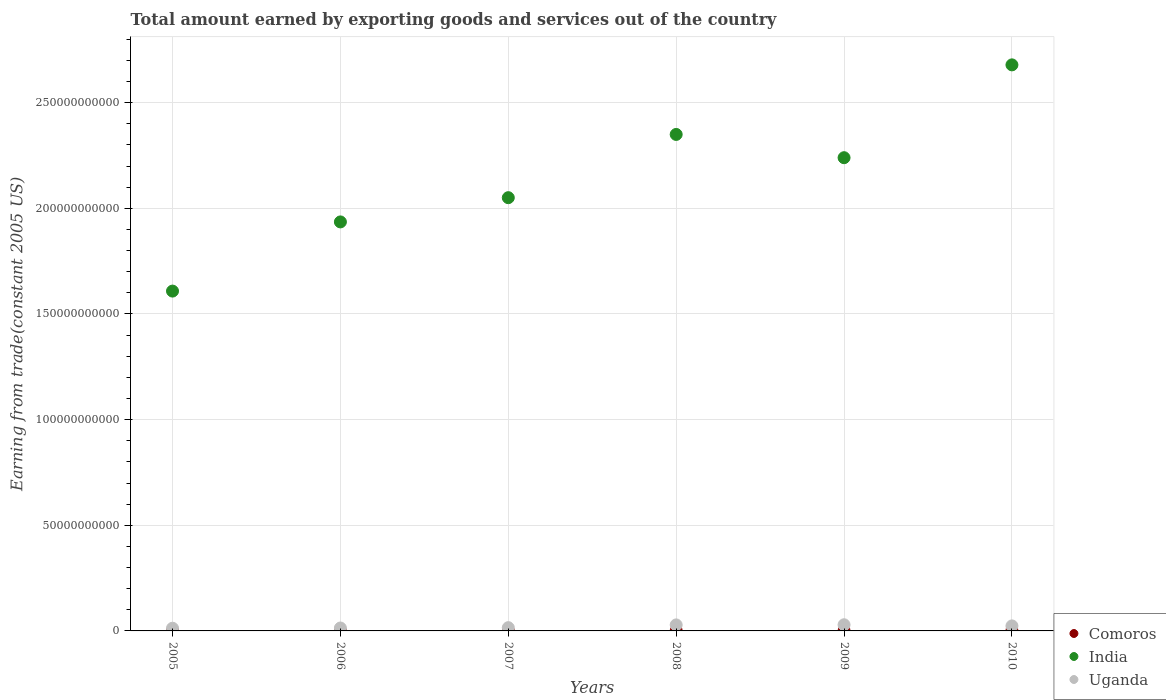How many different coloured dotlines are there?
Make the answer very short. 3. What is the total amount earned by exporting goods and services in India in 2009?
Ensure brevity in your answer.  2.24e+11. Across all years, what is the maximum total amount earned by exporting goods and services in Uganda?
Offer a very short reply. 2.91e+09. Across all years, what is the minimum total amount earned by exporting goods and services in Comoros?
Offer a terse response. 5.71e+07. In which year was the total amount earned by exporting goods and services in Uganda maximum?
Ensure brevity in your answer.  2009. In which year was the total amount earned by exporting goods and services in Uganda minimum?
Give a very brief answer. 2005. What is the total total amount earned by exporting goods and services in India in the graph?
Your response must be concise. 1.29e+12. What is the difference between the total amount earned by exporting goods and services in Uganda in 2005 and that in 2010?
Your response must be concise. -1.09e+09. What is the difference between the total amount earned by exporting goods and services in Uganda in 2009 and the total amount earned by exporting goods and services in Comoros in 2010?
Offer a very short reply. 2.81e+09. What is the average total amount earned by exporting goods and services in Uganda per year?
Your answer should be very brief. 2.06e+09. In the year 2005, what is the difference between the total amount earned by exporting goods and services in Uganda and total amount earned by exporting goods and services in India?
Give a very brief answer. -1.60e+11. In how many years, is the total amount earned by exporting goods and services in Uganda greater than 40000000000 US$?
Your answer should be very brief. 0. What is the ratio of the total amount earned by exporting goods and services in India in 2006 to that in 2010?
Offer a very short reply. 0.72. Is the total amount earned by exporting goods and services in Comoros in 2005 less than that in 2008?
Ensure brevity in your answer.  Yes. What is the difference between the highest and the second highest total amount earned by exporting goods and services in India?
Your answer should be very brief. 3.29e+1. What is the difference between the highest and the lowest total amount earned by exporting goods and services in Comoros?
Your answer should be compact. 5.06e+07. Is it the case that in every year, the sum of the total amount earned by exporting goods and services in Comoros and total amount earned by exporting goods and services in Uganda  is greater than the total amount earned by exporting goods and services in India?
Ensure brevity in your answer.  No. Is the total amount earned by exporting goods and services in Comoros strictly greater than the total amount earned by exporting goods and services in Uganda over the years?
Your answer should be compact. No. How many dotlines are there?
Your answer should be compact. 3. How many years are there in the graph?
Offer a very short reply. 6. What is the difference between two consecutive major ticks on the Y-axis?
Your answer should be very brief. 5.00e+1. Where does the legend appear in the graph?
Give a very brief answer. Bottom right. How many legend labels are there?
Your response must be concise. 3. What is the title of the graph?
Make the answer very short. Total amount earned by exporting goods and services out of the country. Does "Virgin Islands" appear as one of the legend labels in the graph?
Offer a very short reply. No. What is the label or title of the X-axis?
Provide a succinct answer. Years. What is the label or title of the Y-axis?
Your answer should be very brief. Earning from trade(constant 2005 US). What is the Earning from trade(constant 2005 US) of Comoros in 2005?
Provide a short and direct response. 5.71e+07. What is the Earning from trade(constant 2005 US) in India in 2005?
Provide a succinct answer. 1.61e+11. What is the Earning from trade(constant 2005 US) of Uganda in 2005?
Give a very brief answer. 1.28e+09. What is the Earning from trade(constant 2005 US) of Comoros in 2006?
Ensure brevity in your answer.  5.81e+07. What is the Earning from trade(constant 2005 US) in India in 2006?
Offer a very short reply. 1.94e+11. What is the Earning from trade(constant 2005 US) in Uganda in 2006?
Offer a terse response. 1.38e+09. What is the Earning from trade(constant 2005 US) in Comoros in 2007?
Your answer should be compact. 9.43e+07. What is the Earning from trade(constant 2005 US) in India in 2007?
Ensure brevity in your answer.  2.05e+11. What is the Earning from trade(constant 2005 US) in Uganda in 2007?
Your answer should be compact. 1.54e+09. What is the Earning from trade(constant 2005 US) in Comoros in 2008?
Keep it short and to the point. 9.09e+07. What is the Earning from trade(constant 2005 US) in India in 2008?
Keep it short and to the point. 2.35e+11. What is the Earning from trade(constant 2005 US) in Uganda in 2008?
Ensure brevity in your answer.  2.85e+09. What is the Earning from trade(constant 2005 US) in Comoros in 2009?
Your response must be concise. 8.47e+07. What is the Earning from trade(constant 2005 US) of India in 2009?
Offer a very short reply. 2.24e+11. What is the Earning from trade(constant 2005 US) in Uganda in 2009?
Make the answer very short. 2.91e+09. What is the Earning from trade(constant 2005 US) of Comoros in 2010?
Provide a succinct answer. 1.08e+08. What is the Earning from trade(constant 2005 US) in India in 2010?
Make the answer very short. 2.68e+11. What is the Earning from trade(constant 2005 US) in Uganda in 2010?
Offer a terse response. 2.37e+09. Across all years, what is the maximum Earning from trade(constant 2005 US) of Comoros?
Your response must be concise. 1.08e+08. Across all years, what is the maximum Earning from trade(constant 2005 US) in India?
Offer a very short reply. 2.68e+11. Across all years, what is the maximum Earning from trade(constant 2005 US) of Uganda?
Your response must be concise. 2.91e+09. Across all years, what is the minimum Earning from trade(constant 2005 US) in Comoros?
Provide a succinct answer. 5.71e+07. Across all years, what is the minimum Earning from trade(constant 2005 US) in India?
Provide a succinct answer. 1.61e+11. Across all years, what is the minimum Earning from trade(constant 2005 US) in Uganda?
Ensure brevity in your answer.  1.28e+09. What is the total Earning from trade(constant 2005 US) of Comoros in the graph?
Your answer should be compact. 4.93e+08. What is the total Earning from trade(constant 2005 US) in India in the graph?
Your response must be concise. 1.29e+12. What is the total Earning from trade(constant 2005 US) in Uganda in the graph?
Ensure brevity in your answer.  1.23e+1. What is the difference between the Earning from trade(constant 2005 US) of Comoros in 2005 and that in 2006?
Offer a terse response. -9.93e+05. What is the difference between the Earning from trade(constant 2005 US) in India in 2005 and that in 2006?
Keep it short and to the point. -3.27e+1. What is the difference between the Earning from trade(constant 2005 US) of Uganda in 2005 and that in 2006?
Your answer should be very brief. -9.92e+07. What is the difference between the Earning from trade(constant 2005 US) in Comoros in 2005 and that in 2007?
Provide a succinct answer. -3.72e+07. What is the difference between the Earning from trade(constant 2005 US) in India in 2005 and that in 2007?
Offer a very short reply. -4.42e+1. What is the difference between the Earning from trade(constant 2005 US) of Uganda in 2005 and that in 2007?
Your response must be concise. -2.66e+08. What is the difference between the Earning from trade(constant 2005 US) in Comoros in 2005 and that in 2008?
Your response must be concise. -3.38e+07. What is the difference between the Earning from trade(constant 2005 US) in India in 2005 and that in 2008?
Your response must be concise. -7.41e+1. What is the difference between the Earning from trade(constant 2005 US) of Uganda in 2005 and that in 2008?
Ensure brevity in your answer.  -1.57e+09. What is the difference between the Earning from trade(constant 2005 US) in Comoros in 2005 and that in 2009?
Offer a very short reply. -2.76e+07. What is the difference between the Earning from trade(constant 2005 US) of India in 2005 and that in 2009?
Your answer should be compact. -6.31e+1. What is the difference between the Earning from trade(constant 2005 US) in Uganda in 2005 and that in 2009?
Your answer should be compact. -1.64e+09. What is the difference between the Earning from trade(constant 2005 US) of Comoros in 2005 and that in 2010?
Provide a succinct answer. -5.06e+07. What is the difference between the Earning from trade(constant 2005 US) of India in 2005 and that in 2010?
Keep it short and to the point. -1.07e+11. What is the difference between the Earning from trade(constant 2005 US) in Uganda in 2005 and that in 2010?
Your answer should be very brief. -1.09e+09. What is the difference between the Earning from trade(constant 2005 US) in Comoros in 2006 and that in 2007?
Give a very brief answer. -3.62e+07. What is the difference between the Earning from trade(constant 2005 US) in India in 2006 and that in 2007?
Give a very brief answer. -1.15e+1. What is the difference between the Earning from trade(constant 2005 US) of Uganda in 2006 and that in 2007?
Your answer should be compact. -1.67e+08. What is the difference between the Earning from trade(constant 2005 US) of Comoros in 2006 and that in 2008?
Your answer should be very brief. -3.28e+07. What is the difference between the Earning from trade(constant 2005 US) of India in 2006 and that in 2008?
Your response must be concise. -4.14e+1. What is the difference between the Earning from trade(constant 2005 US) in Uganda in 2006 and that in 2008?
Provide a short and direct response. -1.47e+09. What is the difference between the Earning from trade(constant 2005 US) in Comoros in 2006 and that in 2009?
Give a very brief answer. -2.66e+07. What is the difference between the Earning from trade(constant 2005 US) in India in 2006 and that in 2009?
Offer a terse response. -3.04e+1. What is the difference between the Earning from trade(constant 2005 US) in Uganda in 2006 and that in 2009?
Provide a succinct answer. -1.54e+09. What is the difference between the Earning from trade(constant 2005 US) of Comoros in 2006 and that in 2010?
Ensure brevity in your answer.  -4.97e+07. What is the difference between the Earning from trade(constant 2005 US) of India in 2006 and that in 2010?
Offer a very short reply. -7.43e+1. What is the difference between the Earning from trade(constant 2005 US) in Uganda in 2006 and that in 2010?
Your answer should be very brief. -9.94e+08. What is the difference between the Earning from trade(constant 2005 US) in Comoros in 2007 and that in 2008?
Give a very brief answer. 3.33e+06. What is the difference between the Earning from trade(constant 2005 US) in India in 2007 and that in 2008?
Offer a very short reply. -2.99e+1. What is the difference between the Earning from trade(constant 2005 US) of Uganda in 2007 and that in 2008?
Make the answer very short. -1.30e+09. What is the difference between the Earning from trade(constant 2005 US) of Comoros in 2007 and that in 2009?
Offer a terse response. 9.60e+06. What is the difference between the Earning from trade(constant 2005 US) in India in 2007 and that in 2009?
Your response must be concise. -1.89e+1. What is the difference between the Earning from trade(constant 2005 US) in Uganda in 2007 and that in 2009?
Give a very brief answer. -1.37e+09. What is the difference between the Earning from trade(constant 2005 US) in Comoros in 2007 and that in 2010?
Give a very brief answer. -1.35e+07. What is the difference between the Earning from trade(constant 2005 US) of India in 2007 and that in 2010?
Provide a short and direct response. -6.29e+1. What is the difference between the Earning from trade(constant 2005 US) in Uganda in 2007 and that in 2010?
Keep it short and to the point. -8.27e+08. What is the difference between the Earning from trade(constant 2005 US) in Comoros in 2008 and that in 2009?
Your answer should be compact. 6.27e+06. What is the difference between the Earning from trade(constant 2005 US) in India in 2008 and that in 2009?
Make the answer very short. 1.10e+1. What is the difference between the Earning from trade(constant 2005 US) in Uganda in 2008 and that in 2009?
Your response must be concise. -6.62e+07. What is the difference between the Earning from trade(constant 2005 US) in Comoros in 2008 and that in 2010?
Keep it short and to the point. -1.68e+07. What is the difference between the Earning from trade(constant 2005 US) of India in 2008 and that in 2010?
Your response must be concise. -3.29e+1. What is the difference between the Earning from trade(constant 2005 US) of Uganda in 2008 and that in 2010?
Keep it short and to the point. 4.77e+08. What is the difference between the Earning from trade(constant 2005 US) in Comoros in 2009 and that in 2010?
Your answer should be compact. -2.31e+07. What is the difference between the Earning from trade(constant 2005 US) in India in 2009 and that in 2010?
Provide a short and direct response. -4.39e+1. What is the difference between the Earning from trade(constant 2005 US) of Uganda in 2009 and that in 2010?
Make the answer very short. 5.43e+08. What is the difference between the Earning from trade(constant 2005 US) of Comoros in 2005 and the Earning from trade(constant 2005 US) of India in 2006?
Offer a terse response. -1.94e+11. What is the difference between the Earning from trade(constant 2005 US) of Comoros in 2005 and the Earning from trade(constant 2005 US) of Uganda in 2006?
Offer a terse response. -1.32e+09. What is the difference between the Earning from trade(constant 2005 US) in India in 2005 and the Earning from trade(constant 2005 US) in Uganda in 2006?
Make the answer very short. 1.59e+11. What is the difference between the Earning from trade(constant 2005 US) in Comoros in 2005 and the Earning from trade(constant 2005 US) in India in 2007?
Offer a very short reply. -2.05e+11. What is the difference between the Earning from trade(constant 2005 US) of Comoros in 2005 and the Earning from trade(constant 2005 US) of Uganda in 2007?
Give a very brief answer. -1.49e+09. What is the difference between the Earning from trade(constant 2005 US) in India in 2005 and the Earning from trade(constant 2005 US) in Uganda in 2007?
Your answer should be very brief. 1.59e+11. What is the difference between the Earning from trade(constant 2005 US) in Comoros in 2005 and the Earning from trade(constant 2005 US) in India in 2008?
Your answer should be very brief. -2.35e+11. What is the difference between the Earning from trade(constant 2005 US) in Comoros in 2005 and the Earning from trade(constant 2005 US) in Uganda in 2008?
Offer a terse response. -2.79e+09. What is the difference between the Earning from trade(constant 2005 US) in India in 2005 and the Earning from trade(constant 2005 US) in Uganda in 2008?
Provide a short and direct response. 1.58e+11. What is the difference between the Earning from trade(constant 2005 US) of Comoros in 2005 and the Earning from trade(constant 2005 US) of India in 2009?
Your answer should be compact. -2.24e+11. What is the difference between the Earning from trade(constant 2005 US) in Comoros in 2005 and the Earning from trade(constant 2005 US) in Uganda in 2009?
Your response must be concise. -2.86e+09. What is the difference between the Earning from trade(constant 2005 US) in India in 2005 and the Earning from trade(constant 2005 US) in Uganda in 2009?
Give a very brief answer. 1.58e+11. What is the difference between the Earning from trade(constant 2005 US) of Comoros in 2005 and the Earning from trade(constant 2005 US) of India in 2010?
Your answer should be very brief. -2.68e+11. What is the difference between the Earning from trade(constant 2005 US) in Comoros in 2005 and the Earning from trade(constant 2005 US) in Uganda in 2010?
Provide a short and direct response. -2.31e+09. What is the difference between the Earning from trade(constant 2005 US) of India in 2005 and the Earning from trade(constant 2005 US) of Uganda in 2010?
Your answer should be compact. 1.58e+11. What is the difference between the Earning from trade(constant 2005 US) in Comoros in 2006 and the Earning from trade(constant 2005 US) in India in 2007?
Keep it short and to the point. -2.05e+11. What is the difference between the Earning from trade(constant 2005 US) of Comoros in 2006 and the Earning from trade(constant 2005 US) of Uganda in 2007?
Your answer should be compact. -1.49e+09. What is the difference between the Earning from trade(constant 2005 US) in India in 2006 and the Earning from trade(constant 2005 US) in Uganda in 2007?
Offer a very short reply. 1.92e+11. What is the difference between the Earning from trade(constant 2005 US) of Comoros in 2006 and the Earning from trade(constant 2005 US) of India in 2008?
Provide a succinct answer. -2.35e+11. What is the difference between the Earning from trade(constant 2005 US) in Comoros in 2006 and the Earning from trade(constant 2005 US) in Uganda in 2008?
Provide a short and direct response. -2.79e+09. What is the difference between the Earning from trade(constant 2005 US) in India in 2006 and the Earning from trade(constant 2005 US) in Uganda in 2008?
Your response must be concise. 1.91e+11. What is the difference between the Earning from trade(constant 2005 US) of Comoros in 2006 and the Earning from trade(constant 2005 US) of India in 2009?
Provide a succinct answer. -2.24e+11. What is the difference between the Earning from trade(constant 2005 US) of Comoros in 2006 and the Earning from trade(constant 2005 US) of Uganda in 2009?
Offer a terse response. -2.86e+09. What is the difference between the Earning from trade(constant 2005 US) of India in 2006 and the Earning from trade(constant 2005 US) of Uganda in 2009?
Give a very brief answer. 1.91e+11. What is the difference between the Earning from trade(constant 2005 US) of Comoros in 2006 and the Earning from trade(constant 2005 US) of India in 2010?
Ensure brevity in your answer.  -2.68e+11. What is the difference between the Earning from trade(constant 2005 US) in Comoros in 2006 and the Earning from trade(constant 2005 US) in Uganda in 2010?
Offer a very short reply. -2.31e+09. What is the difference between the Earning from trade(constant 2005 US) in India in 2006 and the Earning from trade(constant 2005 US) in Uganda in 2010?
Your answer should be compact. 1.91e+11. What is the difference between the Earning from trade(constant 2005 US) of Comoros in 2007 and the Earning from trade(constant 2005 US) of India in 2008?
Provide a short and direct response. -2.35e+11. What is the difference between the Earning from trade(constant 2005 US) of Comoros in 2007 and the Earning from trade(constant 2005 US) of Uganda in 2008?
Provide a succinct answer. -2.75e+09. What is the difference between the Earning from trade(constant 2005 US) of India in 2007 and the Earning from trade(constant 2005 US) of Uganda in 2008?
Your answer should be compact. 2.02e+11. What is the difference between the Earning from trade(constant 2005 US) in Comoros in 2007 and the Earning from trade(constant 2005 US) in India in 2009?
Provide a succinct answer. -2.24e+11. What is the difference between the Earning from trade(constant 2005 US) of Comoros in 2007 and the Earning from trade(constant 2005 US) of Uganda in 2009?
Your answer should be compact. -2.82e+09. What is the difference between the Earning from trade(constant 2005 US) in India in 2007 and the Earning from trade(constant 2005 US) in Uganda in 2009?
Offer a very short reply. 2.02e+11. What is the difference between the Earning from trade(constant 2005 US) in Comoros in 2007 and the Earning from trade(constant 2005 US) in India in 2010?
Your answer should be compact. -2.68e+11. What is the difference between the Earning from trade(constant 2005 US) in Comoros in 2007 and the Earning from trade(constant 2005 US) in Uganda in 2010?
Your answer should be very brief. -2.28e+09. What is the difference between the Earning from trade(constant 2005 US) of India in 2007 and the Earning from trade(constant 2005 US) of Uganda in 2010?
Your answer should be compact. 2.03e+11. What is the difference between the Earning from trade(constant 2005 US) of Comoros in 2008 and the Earning from trade(constant 2005 US) of India in 2009?
Your answer should be very brief. -2.24e+11. What is the difference between the Earning from trade(constant 2005 US) of Comoros in 2008 and the Earning from trade(constant 2005 US) of Uganda in 2009?
Provide a succinct answer. -2.82e+09. What is the difference between the Earning from trade(constant 2005 US) of India in 2008 and the Earning from trade(constant 2005 US) of Uganda in 2009?
Keep it short and to the point. 2.32e+11. What is the difference between the Earning from trade(constant 2005 US) of Comoros in 2008 and the Earning from trade(constant 2005 US) of India in 2010?
Give a very brief answer. -2.68e+11. What is the difference between the Earning from trade(constant 2005 US) in Comoros in 2008 and the Earning from trade(constant 2005 US) in Uganda in 2010?
Your answer should be compact. -2.28e+09. What is the difference between the Earning from trade(constant 2005 US) of India in 2008 and the Earning from trade(constant 2005 US) of Uganda in 2010?
Ensure brevity in your answer.  2.33e+11. What is the difference between the Earning from trade(constant 2005 US) in Comoros in 2009 and the Earning from trade(constant 2005 US) in India in 2010?
Make the answer very short. -2.68e+11. What is the difference between the Earning from trade(constant 2005 US) of Comoros in 2009 and the Earning from trade(constant 2005 US) of Uganda in 2010?
Provide a short and direct response. -2.29e+09. What is the difference between the Earning from trade(constant 2005 US) of India in 2009 and the Earning from trade(constant 2005 US) of Uganda in 2010?
Make the answer very short. 2.22e+11. What is the average Earning from trade(constant 2005 US) of Comoros per year?
Offer a very short reply. 8.21e+07. What is the average Earning from trade(constant 2005 US) in India per year?
Give a very brief answer. 2.14e+11. What is the average Earning from trade(constant 2005 US) in Uganda per year?
Your answer should be very brief. 2.06e+09. In the year 2005, what is the difference between the Earning from trade(constant 2005 US) of Comoros and Earning from trade(constant 2005 US) of India?
Offer a terse response. -1.61e+11. In the year 2005, what is the difference between the Earning from trade(constant 2005 US) in Comoros and Earning from trade(constant 2005 US) in Uganda?
Your answer should be very brief. -1.22e+09. In the year 2005, what is the difference between the Earning from trade(constant 2005 US) in India and Earning from trade(constant 2005 US) in Uganda?
Offer a terse response. 1.60e+11. In the year 2006, what is the difference between the Earning from trade(constant 2005 US) in Comoros and Earning from trade(constant 2005 US) in India?
Your answer should be very brief. -1.94e+11. In the year 2006, what is the difference between the Earning from trade(constant 2005 US) of Comoros and Earning from trade(constant 2005 US) of Uganda?
Your answer should be compact. -1.32e+09. In the year 2006, what is the difference between the Earning from trade(constant 2005 US) in India and Earning from trade(constant 2005 US) in Uganda?
Provide a succinct answer. 1.92e+11. In the year 2007, what is the difference between the Earning from trade(constant 2005 US) in Comoros and Earning from trade(constant 2005 US) in India?
Provide a short and direct response. -2.05e+11. In the year 2007, what is the difference between the Earning from trade(constant 2005 US) of Comoros and Earning from trade(constant 2005 US) of Uganda?
Offer a very short reply. -1.45e+09. In the year 2007, what is the difference between the Earning from trade(constant 2005 US) in India and Earning from trade(constant 2005 US) in Uganda?
Your response must be concise. 2.04e+11. In the year 2008, what is the difference between the Earning from trade(constant 2005 US) in Comoros and Earning from trade(constant 2005 US) in India?
Your answer should be very brief. -2.35e+11. In the year 2008, what is the difference between the Earning from trade(constant 2005 US) of Comoros and Earning from trade(constant 2005 US) of Uganda?
Your answer should be very brief. -2.76e+09. In the year 2008, what is the difference between the Earning from trade(constant 2005 US) in India and Earning from trade(constant 2005 US) in Uganda?
Give a very brief answer. 2.32e+11. In the year 2009, what is the difference between the Earning from trade(constant 2005 US) in Comoros and Earning from trade(constant 2005 US) in India?
Your answer should be very brief. -2.24e+11. In the year 2009, what is the difference between the Earning from trade(constant 2005 US) in Comoros and Earning from trade(constant 2005 US) in Uganda?
Make the answer very short. -2.83e+09. In the year 2009, what is the difference between the Earning from trade(constant 2005 US) of India and Earning from trade(constant 2005 US) of Uganda?
Your response must be concise. 2.21e+11. In the year 2010, what is the difference between the Earning from trade(constant 2005 US) in Comoros and Earning from trade(constant 2005 US) in India?
Your answer should be very brief. -2.68e+11. In the year 2010, what is the difference between the Earning from trade(constant 2005 US) of Comoros and Earning from trade(constant 2005 US) of Uganda?
Provide a succinct answer. -2.26e+09. In the year 2010, what is the difference between the Earning from trade(constant 2005 US) of India and Earning from trade(constant 2005 US) of Uganda?
Make the answer very short. 2.66e+11. What is the ratio of the Earning from trade(constant 2005 US) in Comoros in 2005 to that in 2006?
Offer a terse response. 0.98. What is the ratio of the Earning from trade(constant 2005 US) in India in 2005 to that in 2006?
Provide a short and direct response. 0.83. What is the ratio of the Earning from trade(constant 2005 US) of Uganda in 2005 to that in 2006?
Keep it short and to the point. 0.93. What is the ratio of the Earning from trade(constant 2005 US) in Comoros in 2005 to that in 2007?
Your answer should be compact. 0.61. What is the ratio of the Earning from trade(constant 2005 US) of India in 2005 to that in 2007?
Offer a very short reply. 0.78. What is the ratio of the Earning from trade(constant 2005 US) of Uganda in 2005 to that in 2007?
Your answer should be very brief. 0.83. What is the ratio of the Earning from trade(constant 2005 US) in Comoros in 2005 to that in 2008?
Ensure brevity in your answer.  0.63. What is the ratio of the Earning from trade(constant 2005 US) of India in 2005 to that in 2008?
Provide a short and direct response. 0.68. What is the ratio of the Earning from trade(constant 2005 US) in Uganda in 2005 to that in 2008?
Offer a very short reply. 0.45. What is the ratio of the Earning from trade(constant 2005 US) in Comoros in 2005 to that in 2009?
Your answer should be very brief. 0.67. What is the ratio of the Earning from trade(constant 2005 US) in India in 2005 to that in 2009?
Keep it short and to the point. 0.72. What is the ratio of the Earning from trade(constant 2005 US) in Uganda in 2005 to that in 2009?
Provide a short and direct response. 0.44. What is the ratio of the Earning from trade(constant 2005 US) in Comoros in 2005 to that in 2010?
Your answer should be very brief. 0.53. What is the ratio of the Earning from trade(constant 2005 US) in India in 2005 to that in 2010?
Provide a short and direct response. 0.6. What is the ratio of the Earning from trade(constant 2005 US) in Uganda in 2005 to that in 2010?
Provide a succinct answer. 0.54. What is the ratio of the Earning from trade(constant 2005 US) of Comoros in 2006 to that in 2007?
Ensure brevity in your answer.  0.62. What is the ratio of the Earning from trade(constant 2005 US) in India in 2006 to that in 2007?
Your answer should be very brief. 0.94. What is the ratio of the Earning from trade(constant 2005 US) in Uganda in 2006 to that in 2007?
Your answer should be compact. 0.89. What is the ratio of the Earning from trade(constant 2005 US) in Comoros in 2006 to that in 2008?
Keep it short and to the point. 0.64. What is the ratio of the Earning from trade(constant 2005 US) of India in 2006 to that in 2008?
Offer a very short reply. 0.82. What is the ratio of the Earning from trade(constant 2005 US) in Uganda in 2006 to that in 2008?
Make the answer very short. 0.48. What is the ratio of the Earning from trade(constant 2005 US) of Comoros in 2006 to that in 2009?
Give a very brief answer. 0.69. What is the ratio of the Earning from trade(constant 2005 US) of India in 2006 to that in 2009?
Your answer should be compact. 0.86. What is the ratio of the Earning from trade(constant 2005 US) in Uganda in 2006 to that in 2009?
Ensure brevity in your answer.  0.47. What is the ratio of the Earning from trade(constant 2005 US) in Comoros in 2006 to that in 2010?
Your answer should be very brief. 0.54. What is the ratio of the Earning from trade(constant 2005 US) in India in 2006 to that in 2010?
Provide a short and direct response. 0.72. What is the ratio of the Earning from trade(constant 2005 US) in Uganda in 2006 to that in 2010?
Your answer should be compact. 0.58. What is the ratio of the Earning from trade(constant 2005 US) in Comoros in 2007 to that in 2008?
Your response must be concise. 1.04. What is the ratio of the Earning from trade(constant 2005 US) of India in 2007 to that in 2008?
Provide a short and direct response. 0.87. What is the ratio of the Earning from trade(constant 2005 US) of Uganda in 2007 to that in 2008?
Offer a terse response. 0.54. What is the ratio of the Earning from trade(constant 2005 US) in Comoros in 2007 to that in 2009?
Make the answer very short. 1.11. What is the ratio of the Earning from trade(constant 2005 US) of India in 2007 to that in 2009?
Offer a very short reply. 0.92. What is the ratio of the Earning from trade(constant 2005 US) of Uganda in 2007 to that in 2009?
Offer a terse response. 0.53. What is the ratio of the Earning from trade(constant 2005 US) of Comoros in 2007 to that in 2010?
Ensure brevity in your answer.  0.87. What is the ratio of the Earning from trade(constant 2005 US) in India in 2007 to that in 2010?
Provide a succinct answer. 0.77. What is the ratio of the Earning from trade(constant 2005 US) in Uganda in 2007 to that in 2010?
Ensure brevity in your answer.  0.65. What is the ratio of the Earning from trade(constant 2005 US) in Comoros in 2008 to that in 2009?
Keep it short and to the point. 1.07. What is the ratio of the Earning from trade(constant 2005 US) in India in 2008 to that in 2009?
Make the answer very short. 1.05. What is the ratio of the Earning from trade(constant 2005 US) in Uganda in 2008 to that in 2009?
Give a very brief answer. 0.98. What is the ratio of the Earning from trade(constant 2005 US) in Comoros in 2008 to that in 2010?
Your answer should be compact. 0.84. What is the ratio of the Earning from trade(constant 2005 US) in India in 2008 to that in 2010?
Make the answer very short. 0.88. What is the ratio of the Earning from trade(constant 2005 US) of Uganda in 2008 to that in 2010?
Your answer should be very brief. 1.2. What is the ratio of the Earning from trade(constant 2005 US) in Comoros in 2009 to that in 2010?
Your response must be concise. 0.79. What is the ratio of the Earning from trade(constant 2005 US) of India in 2009 to that in 2010?
Keep it short and to the point. 0.84. What is the ratio of the Earning from trade(constant 2005 US) of Uganda in 2009 to that in 2010?
Give a very brief answer. 1.23. What is the difference between the highest and the second highest Earning from trade(constant 2005 US) of Comoros?
Keep it short and to the point. 1.35e+07. What is the difference between the highest and the second highest Earning from trade(constant 2005 US) of India?
Your answer should be very brief. 3.29e+1. What is the difference between the highest and the second highest Earning from trade(constant 2005 US) of Uganda?
Offer a very short reply. 6.62e+07. What is the difference between the highest and the lowest Earning from trade(constant 2005 US) of Comoros?
Offer a terse response. 5.06e+07. What is the difference between the highest and the lowest Earning from trade(constant 2005 US) of India?
Your answer should be compact. 1.07e+11. What is the difference between the highest and the lowest Earning from trade(constant 2005 US) in Uganda?
Provide a succinct answer. 1.64e+09. 